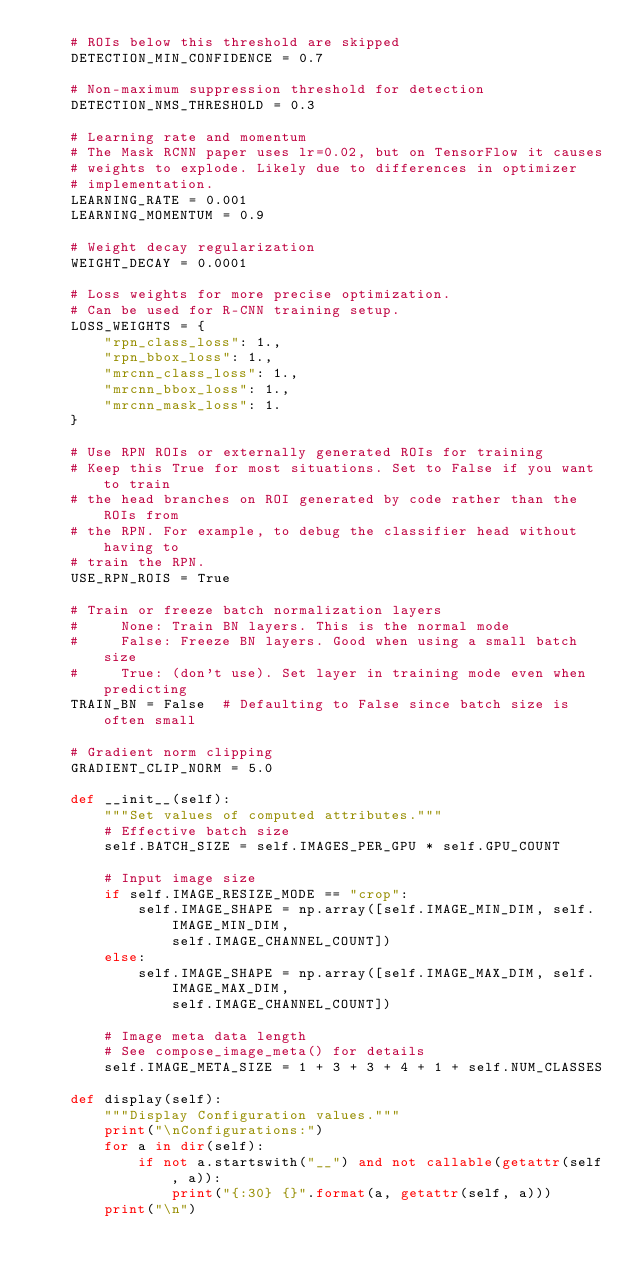Convert code to text. <code><loc_0><loc_0><loc_500><loc_500><_Python_>    # ROIs below this threshold are skipped
    DETECTION_MIN_CONFIDENCE = 0.7

    # Non-maximum suppression threshold for detection
    DETECTION_NMS_THRESHOLD = 0.3

    # Learning rate and momentum
    # The Mask RCNN paper uses lr=0.02, but on TensorFlow it causes
    # weights to explode. Likely due to differences in optimizer
    # implementation.
    LEARNING_RATE = 0.001
    LEARNING_MOMENTUM = 0.9

    # Weight decay regularization
    WEIGHT_DECAY = 0.0001

    # Loss weights for more precise optimization.
    # Can be used for R-CNN training setup.
    LOSS_WEIGHTS = {
        "rpn_class_loss": 1.,
        "rpn_bbox_loss": 1.,
        "mrcnn_class_loss": 1.,
        "mrcnn_bbox_loss": 1.,
        "mrcnn_mask_loss": 1.
    }

    # Use RPN ROIs or externally generated ROIs for training
    # Keep this True for most situations. Set to False if you want to train
    # the head branches on ROI generated by code rather than the ROIs from
    # the RPN. For example, to debug the classifier head without having to
    # train the RPN.
    USE_RPN_ROIS = True

    # Train or freeze batch normalization layers
    #     None: Train BN layers. This is the normal mode
    #     False: Freeze BN layers. Good when using a small batch size
    #     True: (don't use). Set layer in training mode even when predicting
    TRAIN_BN = False  # Defaulting to False since batch size is often small

    # Gradient norm clipping
    GRADIENT_CLIP_NORM = 5.0

    def __init__(self):
        """Set values of computed attributes."""
        # Effective batch size
        self.BATCH_SIZE = self.IMAGES_PER_GPU * self.GPU_COUNT

        # Input image size
        if self.IMAGE_RESIZE_MODE == "crop":
            self.IMAGE_SHAPE = np.array([self.IMAGE_MIN_DIM, self.IMAGE_MIN_DIM,
                self.IMAGE_CHANNEL_COUNT])
        else:
            self.IMAGE_SHAPE = np.array([self.IMAGE_MAX_DIM, self.IMAGE_MAX_DIM,
                self.IMAGE_CHANNEL_COUNT])

        # Image meta data length
        # See compose_image_meta() for details
        self.IMAGE_META_SIZE = 1 + 3 + 3 + 4 + 1 + self.NUM_CLASSES

    def display(self):
        """Display Configuration values."""
        print("\nConfigurations:")
        for a in dir(self):
            if not a.startswith("__") and not callable(getattr(self, a)):
                print("{:30} {}".format(a, getattr(self, a)))
        print("\n")
</code> 